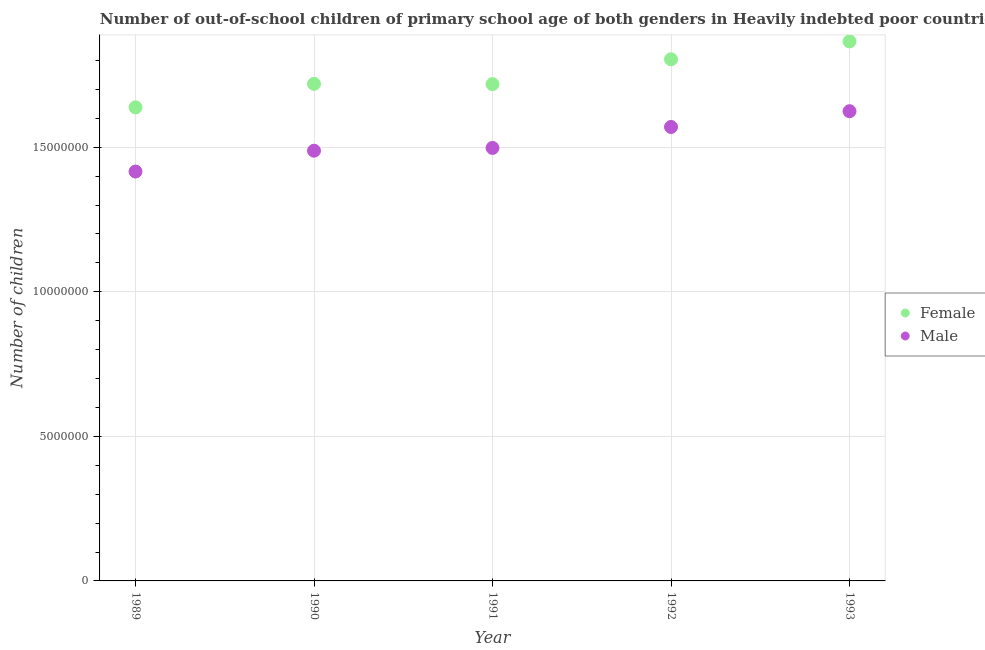What is the number of male out-of-school students in 1993?
Your answer should be very brief. 1.62e+07. Across all years, what is the maximum number of male out-of-school students?
Ensure brevity in your answer.  1.62e+07. Across all years, what is the minimum number of female out-of-school students?
Offer a very short reply. 1.64e+07. What is the total number of male out-of-school students in the graph?
Provide a short and direct response. 7.60e+07. What is the difference between the number of male out-of-school students in 1989 and that in 1992?
Keep it short and to the point. -1.54e+06. What is the difference between the number of male out-of-school students in 1989 and the number of female out-of-school students in 1992?
Provide a short and direct response. -3.88e+06. What is the average number of male out-of-school students per year?
Give a very brief answer. 1.52e+07. In the year 1992, what is the difference between the number of female out-of-school students and number of male out-of-school students?
Ensure brevity in your answer.  2.34e+06. In how many years, is the number of male out-of-school students greater than 1000000?
Provide a succinct answer. 5. What is the ratio of the number of male out-of-school students in 1990 to that in 1992?
Make the answer very short. 0.95. Is the difference between the number of male out-of-school students in 1991 and 1992 greater than the difference between the number of female out-of-school students in 1991 and 1992?
Give a very brief answer. Yes. What is the difference between the highest and the second highest number of female out-of-school students?
Provide a succinct answer. 6.20e+05. What is the difference between the highest and the lowest number of female out-of-school students?
Your answer should be very brief. 2.28e+06. In how many years, is the number of female out-of-school students greater than the average number of female out-of-school students taken over all years?
Offer a very short reply. 2. Is the sum of the number of male out-of-school students in 1991 and 1992 greater than the maximum number of female out-of-school students across all years?
Provide a short and direct response. Yes. Does the number of male out-of-school students monotonically increase over the years?
Your answer should be very brief. Yes. Is the number of male out-of-school students strictly less than the number of female out-of-school students over the years?
Ensure brevity in your answer.  Yes. How many dotlines are there?
Provide a succinct answer. 2. How many years are there in the graph?
Keep it short and to the point. 5. What is the difference between two consecutive major ticks on the Y-axis?
Provide a short and direct response. 5.00e+06. Are the values on the major ticks of Y-axis written in scientific E-notation?
Offer a terse response. No. Does the graph contain any zero values?
Make the answer very short. No. Does the graph contain grids?
Make the answer very short. Yes. Where does the legend appear in the graph?
Your answer should be compact. Center right. What is the title of the graph?
Your answer should be compact. Number of out-of-school children of primary school age of both genders in Heavily indebted poor countries. Does "Electricity" appear as one of the legend labels in the graph?
Your answer should be very brief. No. What is the label or title of the X-axis?
Keep it short and to the point. Year. What is the label or title of the Y-axis?
Ensure brevity in your answer.  Number of children. What is the Number of children of Female in 1989?
Make the answer very short. 1.64e+07. What is the Number of children of Male in 1989?
Your answer should be very brief. 1.42e+07. What is the Number of children in Female in 1990?
Provide a succinct answer. 1.72e+07. What is the Number of children in Male in 1990?
Your answer should be very brief. 1.49e+07. What is the Number of children of Female in 1991?
Ensure brevity in your answer.  1.72e+07. What is the Number of children in Male in 1991?
Your answer should be very brief. 1.50e+07. What is the Number of children in Female in 1992?
Offer a terse response. 1.80e+07. What is the Number of children of Male in 1992?
Give a very brief answer. 1.57e+07. What is the Number of children in Female in 1993?
Your answer should be very brief. 1.87e+07. What is the Number of children of Male in 1993?
Provide a short and direct response. 1.62e+07. Across all years, what is the maximum Number of children in Female?
Keep it short and to the point. 1.87e+07. Across all years, what is the maximum Number of children in Male?
Ensure brevity in your answer.  1.62e+07. Across all years, what is the minimum Number of children of Female?
Your answer should be compact. 1.64e+07. Across all years, what is the minimum Number of children in Male?
Keep it short and to the point. 1.42e+07. What is the total Number of children of Female in the graph?
Offer a very short reply. 8.75e+07. What is the total Number of children in Male in the graph?
Give a very brief answer. 7.60e+07. What is the difference between the Number of children in Female in 1989 and that in 1990?
Offer a terse response. -8.14e+05. What is the difference between the Number of children of Male in 1989 and that in 1990?
Your answer should be compact. -7.20e+05. What is the difference between the Number of children in Female in 1989 and that in 1991?
Keep it short and to the point. -8.04e+05. What is the difference between the Number of children in Male in 1989 and that in 1991?
Provide a short and direct response. -8.16e+05. What is the difference between the Number of children in Female in 1989 and that in 1992?
Your answer should be compact. -1.66e+06. What is the difference between the Number of children of Male in 1989 and that in 1992?
Make the answer very short. -1.54e+06. What is the difference between the Number of children in Female in 1989 and that in 1993?
Make the answer very short. -2.28e+06. What is the difference between the Number of children in Male in 1989 and that in 1993?
Give a very brief answer. -2.09e+06. What is the difference between the Number of children of Female in 1990 and that in 1991?
Provide a succinct answer. 1.02e+04. What is the difference between the Number of children of Male in 1990 and that in 1991?
Make the answer very short. -9.66e+04. What is the difference between the Number of children in Female in 1990 and that in 1992?
Provide a short and direct response. -8.48e+05. What is the difference between the Number of children of Male in 1990 and that in 1992?
Offer a terse response. -8.22e+05. What is the difference between the Number of children of Female in 1990 and that in 1993?
Provide a succinct answer. -1.47e+06. What is the difference between the Number of children in Male in 1990 and that in 1993?
Give a very brief answer. -1.37e+06. What is the difference between the Number of children of Female in 1991 and that in 1992?
Make the answer very short. -8.58e+05. What is the difference between the Number of children in Male in 1991 and that in 1992?
Provide a short and direct response. -7.25e+05. What is the difference between the Number of children of Female in 1991 and that in 1993?
Your answer should be compact. -1.48e+06. What is the difference between the Number of children in Male in 1991 and that in 1993?
Your response must be concise. -1.27e+06. What is the difference between the Number of children of Female in 1992 and that in 1993?
Provide a short and direct response. -6.20e+05. What is the difference between the Number of children in Male in 1992 and that in 1993?
Give a very brief answer. -5.45e+05. What is the difference between the Number of children of Female in 1989 and the Number of children of Male in 1990?
Give a very brief answer. 1.50e+06. What is the difference between the Number of children of Female in 1989 and the Number of children of Male in 1991?
Provide a short and direct response. 1.40e+06. What is the difference between the Number of children in Female in 1989 and the Number of children in Male in 1992?
Ensure brevity in your answer.  6.78e+05. What is the difference between the Number of children in Female in 1989 and the Number of children in Male in 1993?
Keep it short and to the point. 1.33e+05. What is the difference between the Number of children of Female in 1990 and the Number of children of Male in 1991?
Your answer should be very brief. 2.22e+06. What is the difference between the Number of children in Female in 1990 and the Number of children in Male in 1992?
Offer a very short reply. 1.49e+06. What is the difference between the Number of children in Female in 1990 and the Number of children in Male in 1993?
Make the answer very short. 9.47e+05. What is the difference between the Number of children of Female in 1991 and the Number of children of Male in 1992?
Make the answer very short. 1.48e+06. What is the difference between the Number of children in Female in 1991 and the Number of children in Male in 1993?
Offer a very short reply. 9.37e+05. What is the difference between the Number of children of Female in 1992 and the Number of children of Male in 1993?
Offer a terse response. 1.80e+06. What is the average Number of children of Female per year?
Give a very brief answer. 1.75e+07. What is the average Number of children of Male per year?
Your response must be concise. 1.52e+07. In the year 1989, what is the difference between the Number of children in Female and Number of children in Male?
Provide a short and direct response. 2.22e+06. In the year 1990, what is the difference between the Number of children of Female and Number of children of Male?
Provide a short and direct response. 2.31e+06. In the year 1991, what is the difference between the Number of children of Female and Number of children of Male?
Ensure brevity in your answer.  2.21e+06. In the year 1992, what is the difference between the Number of children of Female and Number of children of Male?
Keep it short and to the point. 2.34e+06. In the year 1993, what is the difference between the Number of children in Female and Number of children in Male?
Make the answer very short. 2.41e+06. What is the ratio of the Number of children of Female in 1989 to that in 1990?
Keep it short and to the point. 0.95. What is the ratio of the Number of children in Male in 1989 to that in 1990?
Give a very brief answer. 0.95. What is the ratio of the Number of children of Female in 1989 to that in 1991?
Offer a very short reply. 0.95. What is the ratio of the Number of children of Male in 1989 to that in 1991?
Your answer should be compact. 0.95. What is the ratio of the Number of children in Female in 1989 to that in 1992?
Offer a very short reply. 0.91. What is the ratio of the Number of children of Male in 1989 to that in 1992?
Ensure brevity in your answer.  0.9. What is the ratio of the Number of children of Female in 1989 to that in 1993?
Offer a terse response. 0.88. What is the ratio of the Number of children of Male in 1989 to that in 1993?
Make the answer very short. 0.87. What is the ratio of the Number of children of Female in 1990 to that in 1991?
Provide a short and direct response. 1. What is the ratio of the Number of children of Male in 1990 to that in 1991?
Make the answer very short. 0.99. What is the ratio of the Number of children of Female in 1990 to that in 1992?
Offer a terse response. 0.95. What is the ratio of the Number of children in Male in 1990 to that in 1992?
Ensure brevity in your answer.  0.95. What is the ratio of the Number of children of Female in 1990 to that in 1993?
Your response must be concise. 0.92. What is the ratio of the Number of children in Male in 1990 to that in 1993?
Make the answer very short. 0.92. What is the ratio of the Number of children of Male in 1991 to that in 1992?
Provide a succinct answer. 0.95. What is the ratio of the Number of children of Female in 1991 to that in 1993?
Your answer should be very brief. 0.92. What is the ratio of the Number of children of Male in 1991 to that in 1993?
Provide a short and direct response. 0.92. What is the ratio of the Number of children of Female in 1992 to that in 1993?
Keep it short and to the point. 0.97. What is the ratio of the Number of children of Male in 1992 to that in 1993?
Offer a terse response. 0.97. What is the difference between the highest and the second highest Number of children in Female?
Your answer should be compact. 6.20e+05. What is the difference between the highest and the second highest Number of children of Male?
Keep it short and to the point. 5.45e+05. What is the difference between the highest and the lowest Number of children in Female?
Your answer should be very brief. 2.28e+06. What is the difference between the highest and the lowest Number of children in Male?
Your answer should be very brief. 2.09e+06. 